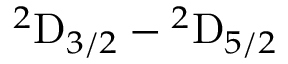Convert formula to latex. <formula><loc_0><loc_0><loc_500><loc_500>{ ^ { 2 } D } _ { 3 / 2 } { - } { ^ { 2 } D } _ { 5 / 2 }</formula> 